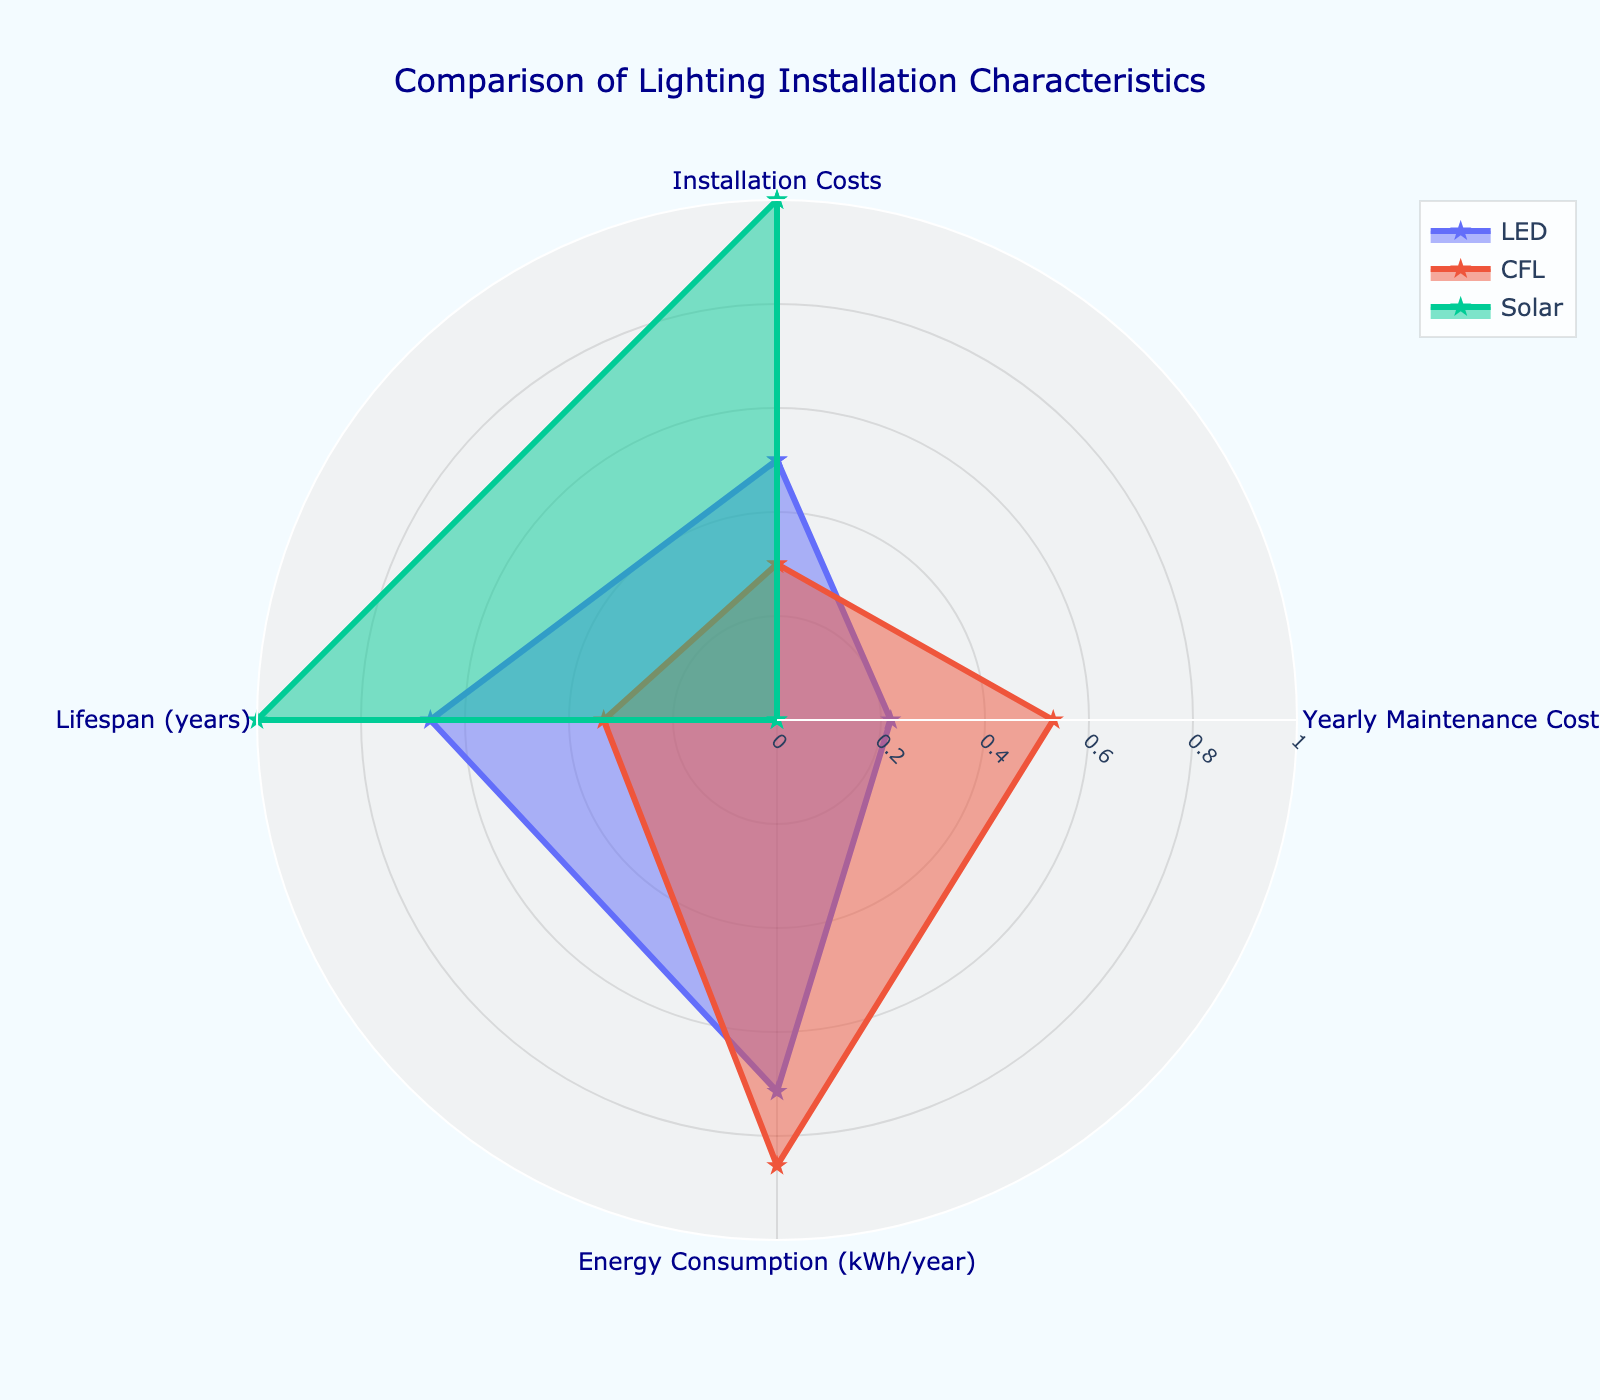What's the title of the figure? The title of the figure is displayed prominently at the top and reads "Comparison of Lighting Installation Characteristics".
Answer: Comparison of Lighting Installation Characteristics Which material type has the highest normalized yearly maintenance costs? By looking at the radar chart, the material type with the furthest point from the center in the "Yearly Maintenance Costs" category is CFL.
Answer: CFL In terms of lifespan, which material ranks highest and lowest? In the radar chart, the material with the point furthest from the center in the "Lifespan" category is Solar, indicating it has the highest lifespan. The material with the point closest to the center is Halogen, indicating it has the lowest lifespan.
Answer: Highest: Solar, Lowest: Halogen Are there any categories where the LED and CFL materials have equal normalized values? By observing the radar chart lines for LED and CFL, none of the points align exactly in any category, indicating they do not have equal normalized values in any of the categories.
Answer: No Which two materials have the smallest difference in normalized installation costs? By comparing the distances from the center for different materials in the "Installation Costs" category, the LED and CFL materials have the most similar distances, indicating the smallest difference.
Answer: LED and CFL Considering installation costs and yearly maintenance costs, which material appears to be most cost-effective? Observing the radar chart, Solar has the highest value in the "Lifespan" category and the lowest value in the "Yearly Maintenance Costs" category. Although its installation cost is higher, it balances out due to lower maintenance costs and a longer lifespan.
Answer: Solar Which material has the lowest normalized values in both yearly maintenance costs and energy consumption? By analyzing the distances from the center for each material, the Solar material has the lowest values in both the "Yearly Maintenance Costs" and "Energy Consumption (kWh/year)" categories.
Answer: Solar Is there a category where all materials have distinctly different normalized values? By looking at each category in the radar chart, "Yearly Maintenance Costs" is a category where LED, CFL, and Solar have distinctly different normalized values.
Answer: Yearly Maintenance Costs 